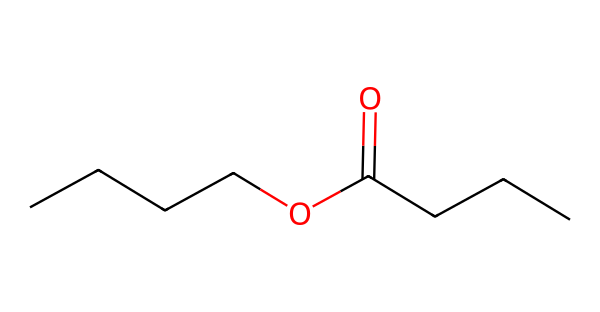What is the name of this ester? The SMILES notation indicates an ester formed from butanol and butyric acid. The given structure corresponds to butyl butyrate.
Answer: butyl butyrate How many carbon atoms are in butyl butyrate? By analyzing the structure from the SMILES notation, there are five carbon atoms in the butyl group and three in the butyrate moiety, totaling eight carbon atoms in the entire structure.
Answer: eight What type of functional group is present in this compound? The presence of the carbonyl group (C=O) and the alkoxy group (–O–C) indicates that this compound is an ester, which is characterized by this specific functional group arrangement.
Answer: ester How many oxygen atoms are in butyl butyrate? From the SMILES representation, we observe there are two oxygen atoms: one in the carbonyl part and one in the ester linkage.
Answer: two What kind of aroma does butyl butyrate evoke? Butyl butyrate is known for its pineapple scent, which is frequently utilized in perfumes and flavorings due to its fruity and sweet aroma profile.
Answer: pineapple What is the molecular formula for butyl butyrate? Based on the carbon, hydrogen, and oxygen counts, the molecular formula is derived as C8H16O2, representing the total counts of each atom present in the structure.
Answer: C8H16O2 